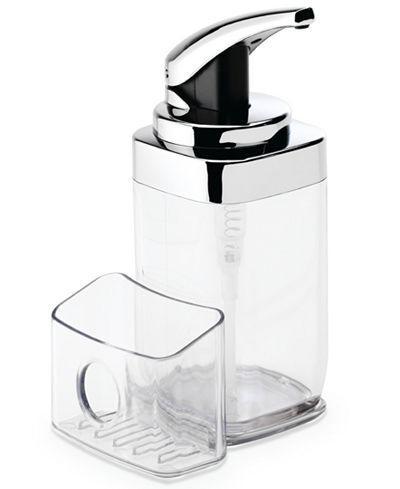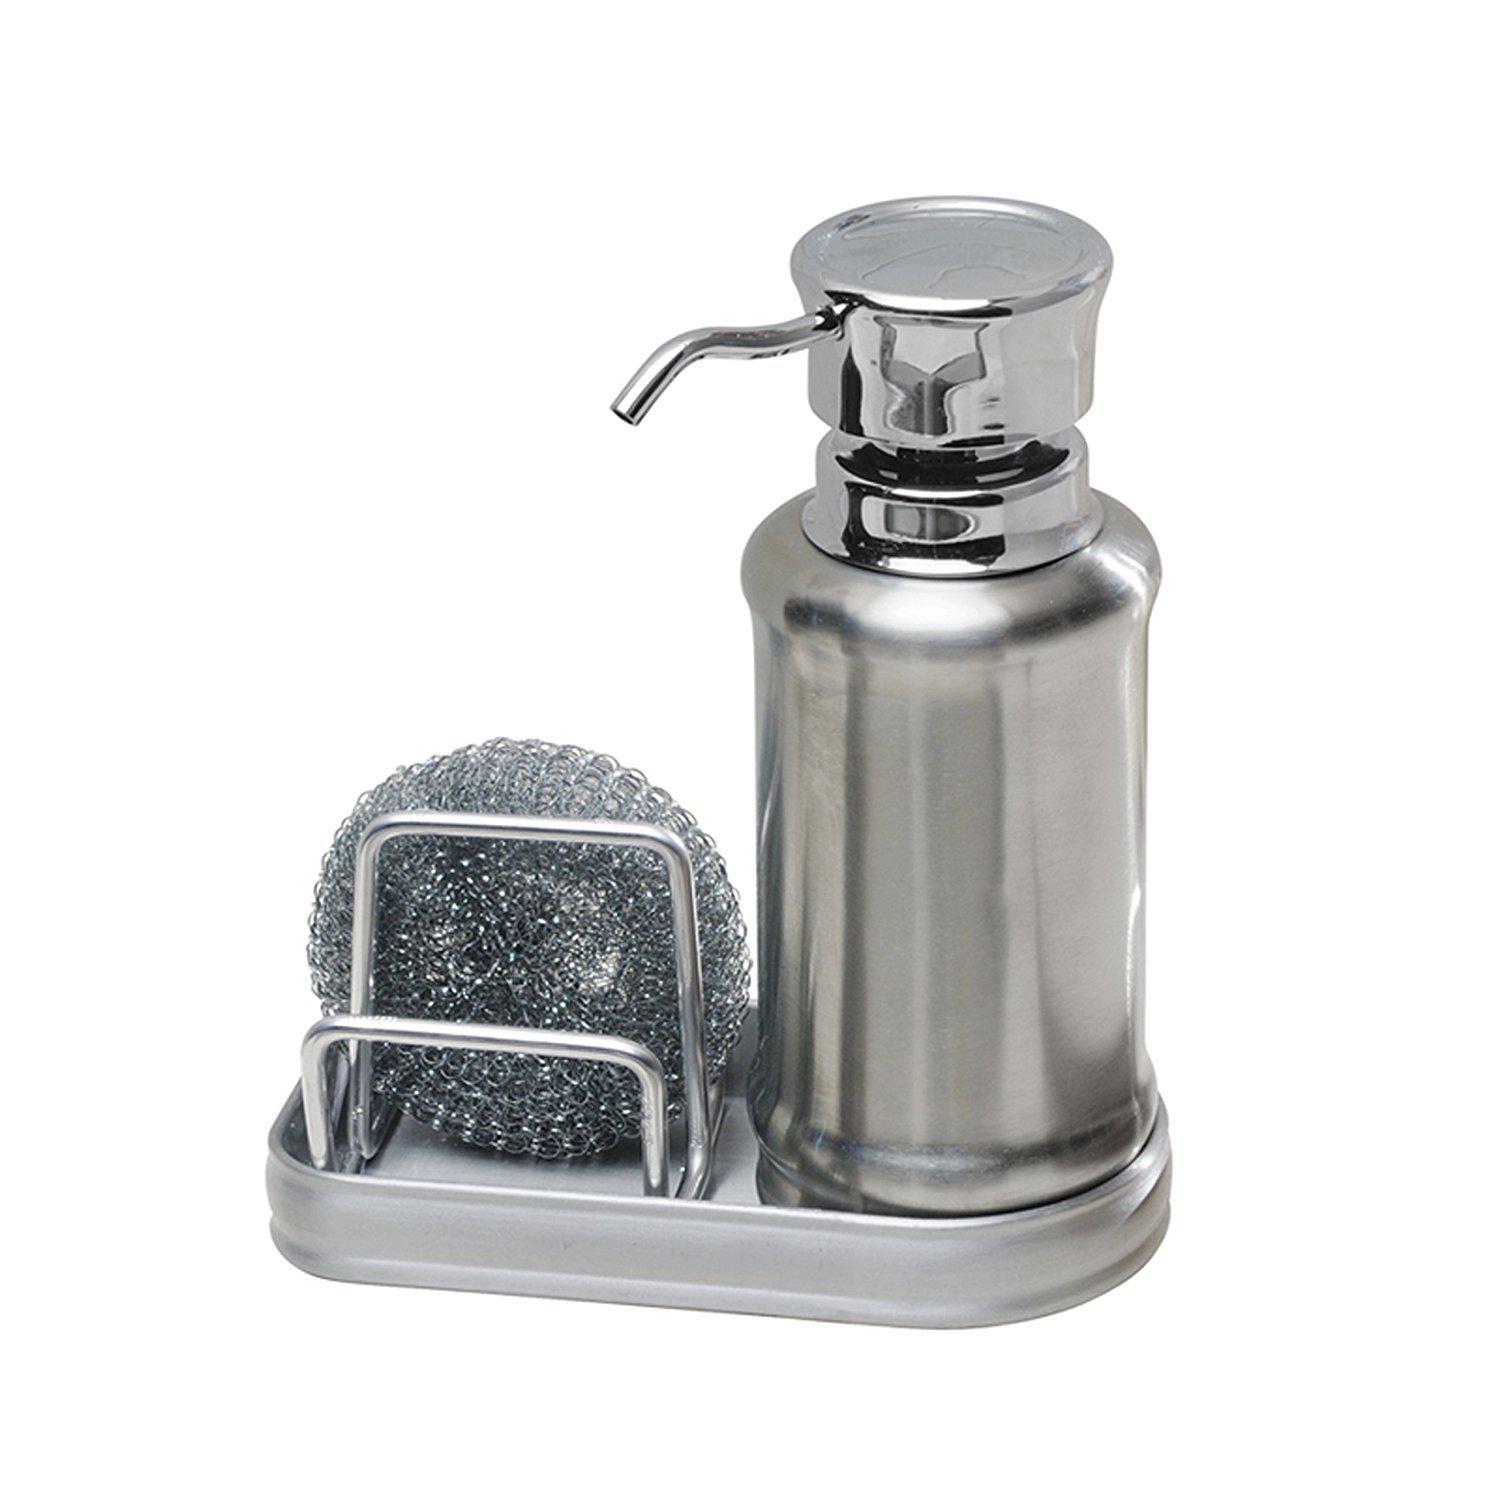The first image is the image on the left, the second image is the image on the right. Analyze the images presented: Is the assertion "None of the soap dispensers have stainless steel tops and at least two of the dispensers are made of clear glass." valid? Answer yes or no. No. The first image is the image on the left, the second image is the image on the right. Considering the images on both sides, is "There are exactly three liquid soap dispenser pumps." valid? Answer yes or no. No. 